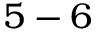Convert formula to latex. <formula><loc_0><loc_0><loc_500><loc_500>5 - 6</formula> 